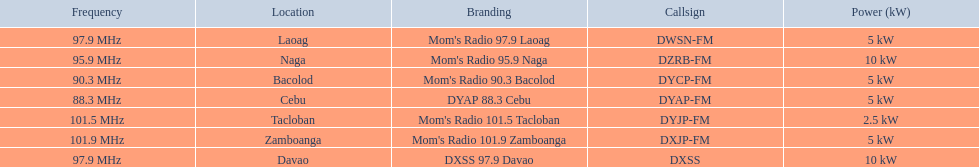What brandings have a power of 5 kw? Mom's Radio 97.9 Laoag, Mom's Radio 90.3 Bacolod, DYAP 88.3 Cebu, Mom's Radio 101.9 Zamboanga. Which of these has a call-sign beginning with dy? Mom's Radio 90.3 Bacolod, DYAP 88.3 Cebu. Which of those uses the lowest frequency? DYAP 88.3 Cebu. 